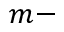Convert formula to latex. <formula><loc_0><loc_0><loc_500><loc_500>m -</formula> 